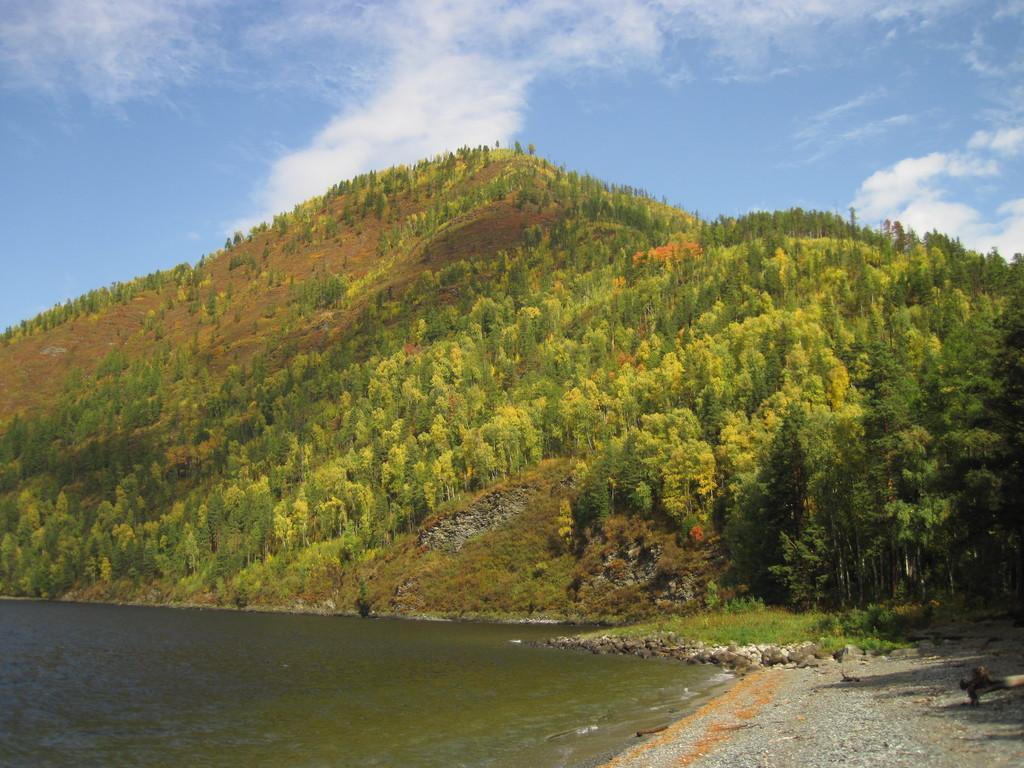Can you describe this image briefly? In the picture we can see water and near to it, we can see stone surface and in the background, we can see a grass and hills and trees on it and we can also see a sky with clouds. 